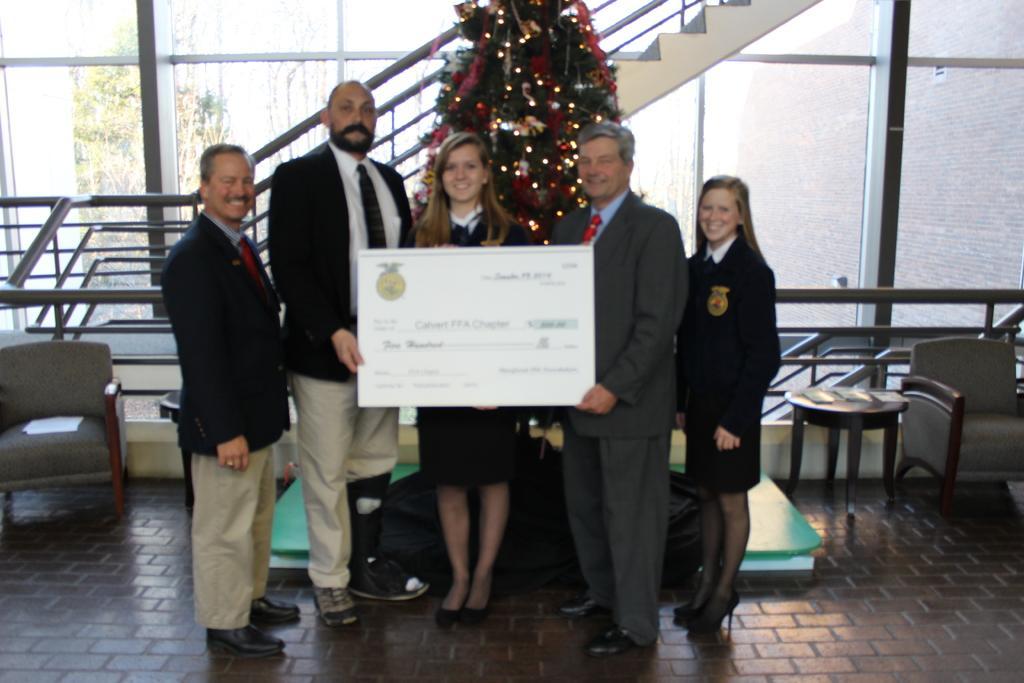What are the persons in the image holding? The persons in the image are holding certificates. What can be seen in the background of the image? There is a Christmas tree, a staircase, a sofa, a table, a glass object, and trees visible in the background of the image. What type of screw can be seen on the toy in the image? There is no toy or screw present in the image. What type of card is visible on the table in the image? There is no card visible on the table in the image. 